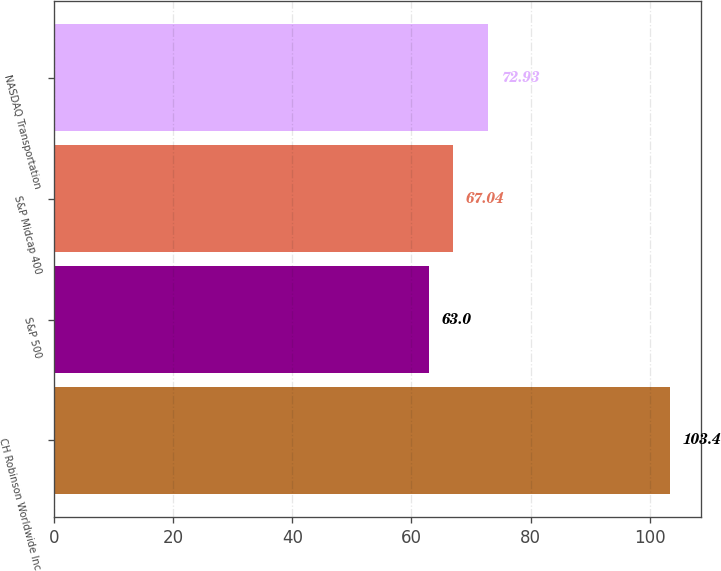Convert chart to OTSL. <chart><loc_0><loc_0><loc_500><loc_500><bar_chart><fcel>CH Robinson Worldwide Inc<fcel>S&P 500<fcel>S&P Midcap 400<fcel>NASDAQ Transportation<nl><fcel>103.4<fcel>63<fcel>67.04<fcel>72.93<nl></chart> 